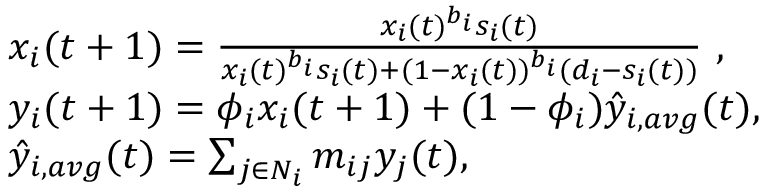Convert formula to latex. <formula><loc_0><loc_0><loc_500><loc_500>\begin{array} { r l } & { x _ { i } ( t + 1 ) = \frac { x _ { i } ( t ) ^ { b _ { i } } s _ { i } ( t ) } { x _ { i } ( t ) ^ { b _ { i } } s _ { i } ( t ) + ( 1 - x _ { i } ( t ) ) ^ { b _ { i } } ( d _ { i } - s _ { i } ( t ) ) } , } \\ & { y _ { i } ( t + 1 ) = \phi _ { i } x _ { i } ( t + 1 ) + ( 1 - \phi _ { i } ) \hat { y } _ { i , a v g } ( t ) , } \\ & { \hat { y } _ { i , a v g } ( t ) = \sum _ { j \in N _ { i } } m _ { i j } y _ { j } ( t ) , } \end{array}</formula> 